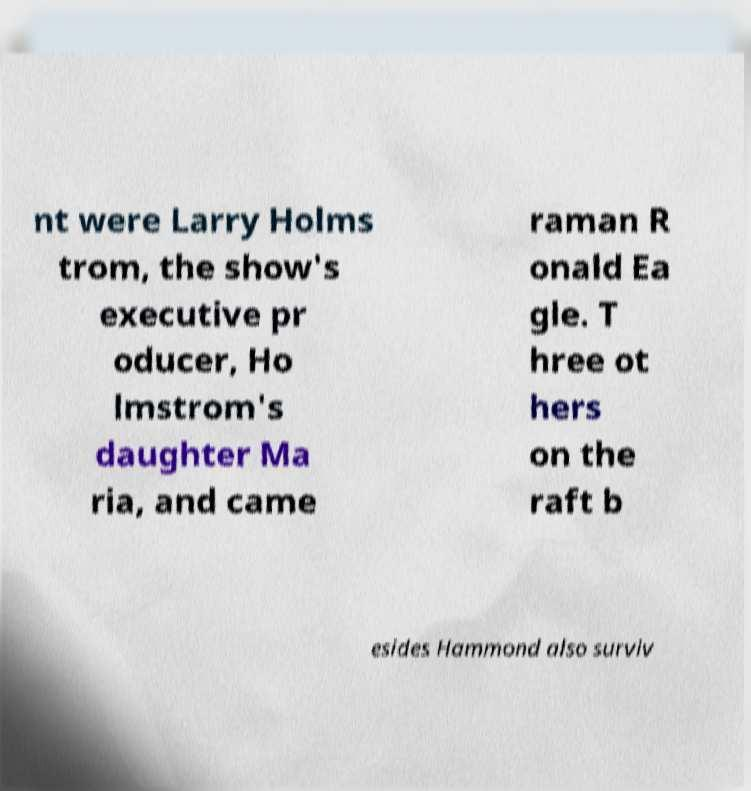What messages or text are displayed in this image? I need them in a readable, typed format. nt were Larry Holms trom, the show's executive pr oducer, Ho lmstrom's daughter Ma ria, and came raman R onald Ea gle. T hree ot hers on the raft b esides Hammond also surviv 